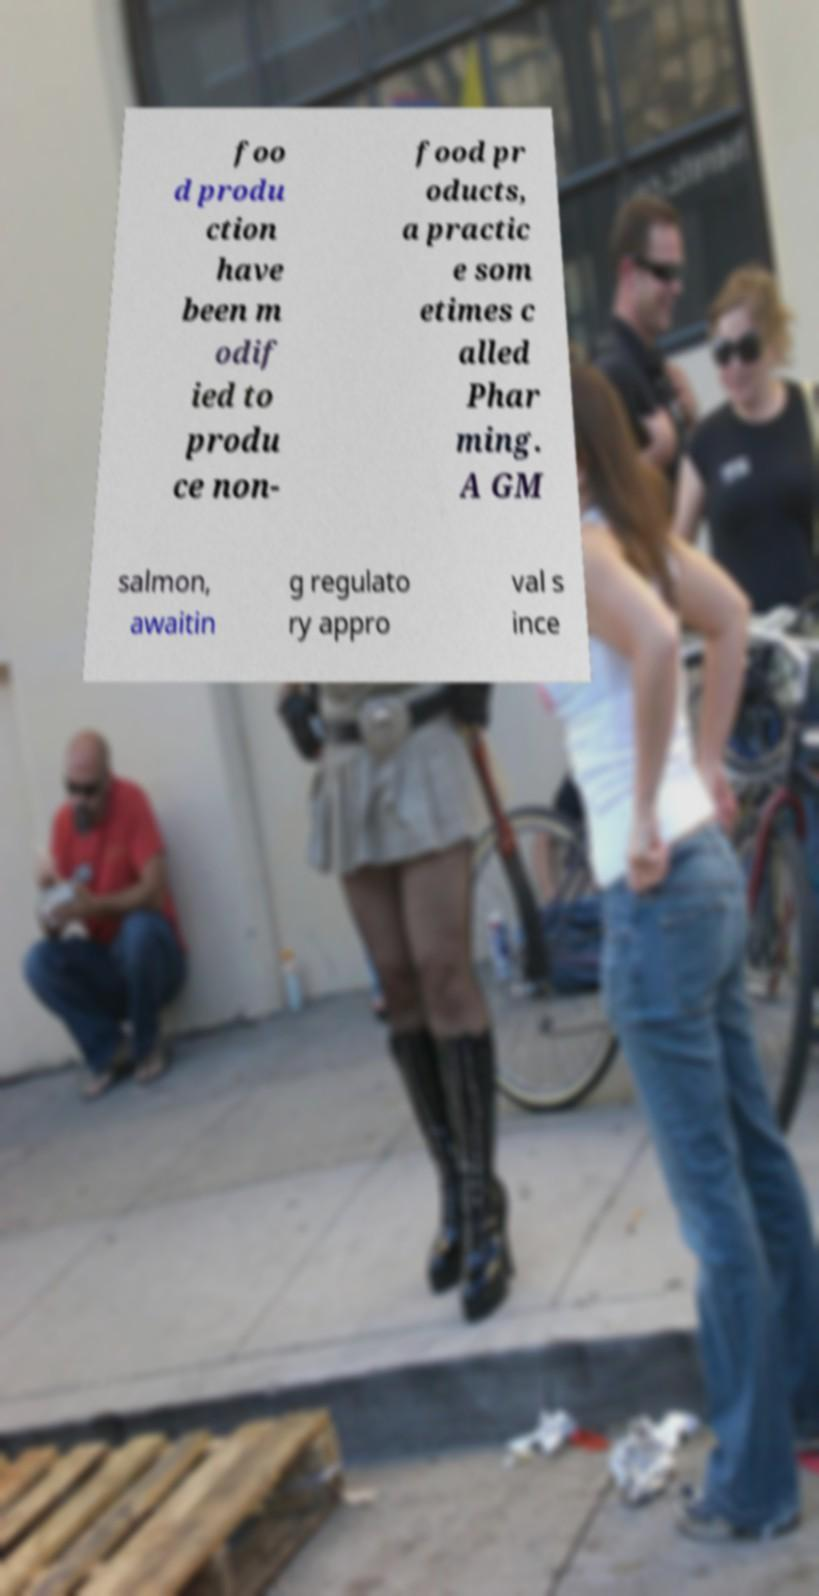Please identify and transcribe the text found in this image. foo d produ ction have been m odif ied to produ ce non- food pr oducts, a practic e som etimes c alled Phar ming. A GM salmon, awaitin g regulato ry appro val s ince 